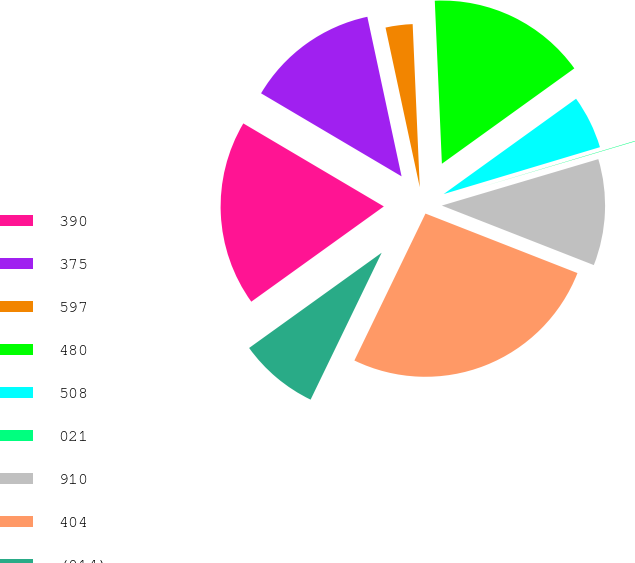Convert chart to OTSL. <chart><loc_0><loc_0><loc_500><loc_500><pie_chart><fcel>390<fcel>375<fcel>597<fcel>480<fcel>508<fcel>021<fcel>910<fcel>404<fcel>(014)<nl><fcel>18.41%<fcel>13.14%<fcel>2.67%<fcel>15.76%<fcel>5.29%<fcel>0.05%<fcel>10.53%<fcel>26.23%<fcel>7.91%<nl></chart> 